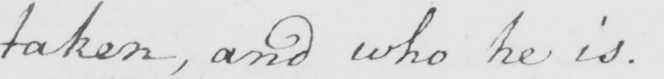Please provide the text content of this handwritten line. taken , and who he is . 